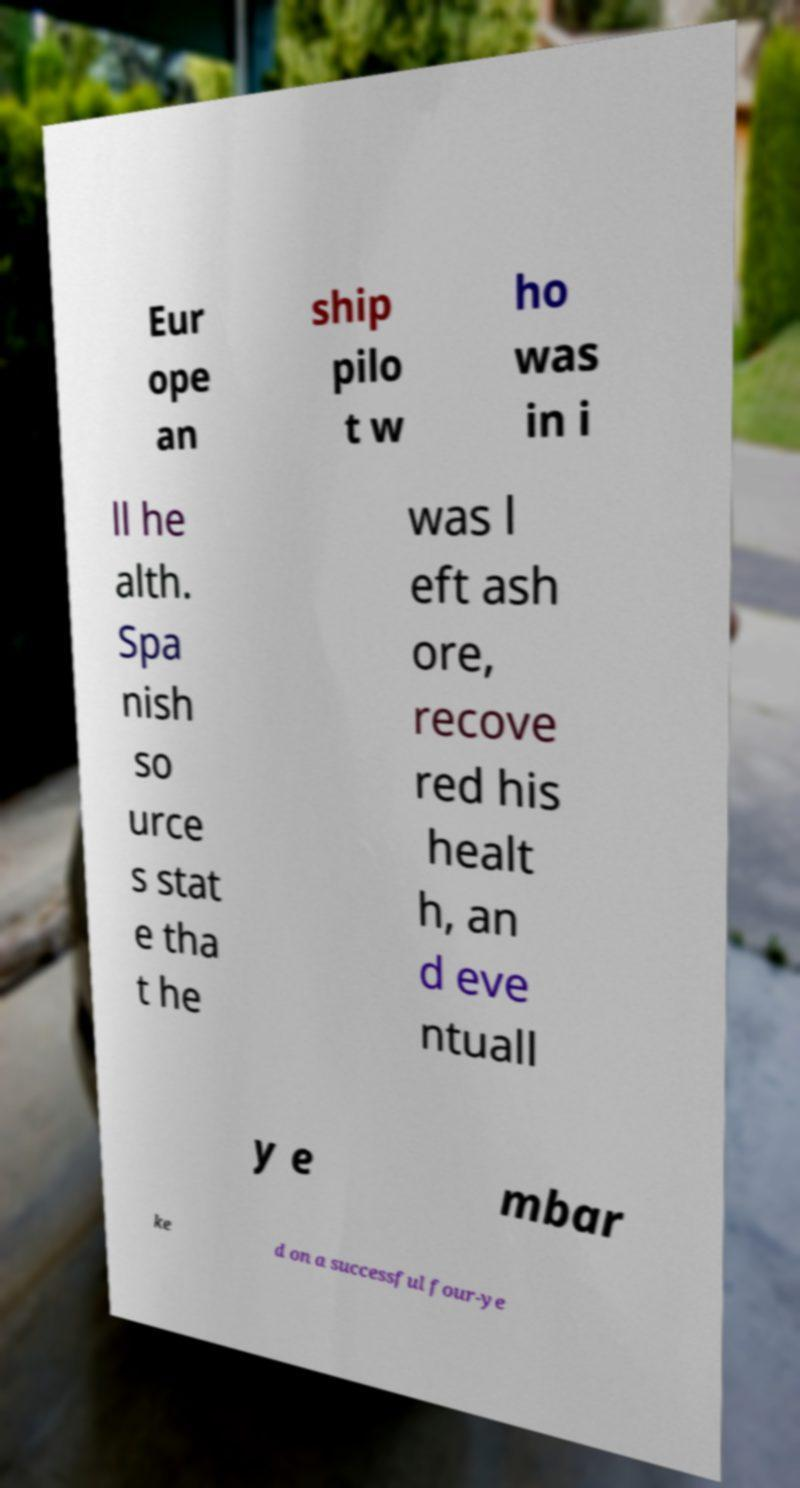Please read and relay the text visible in this image. What does it say? Eur ope an ship pilo t w ho was in i ll he alth. Spa nish so urce s stat e tha t he was l eft ash ore, recove red his healt h, an d eve ntuall y e mbar ke d on a successful four-ye 